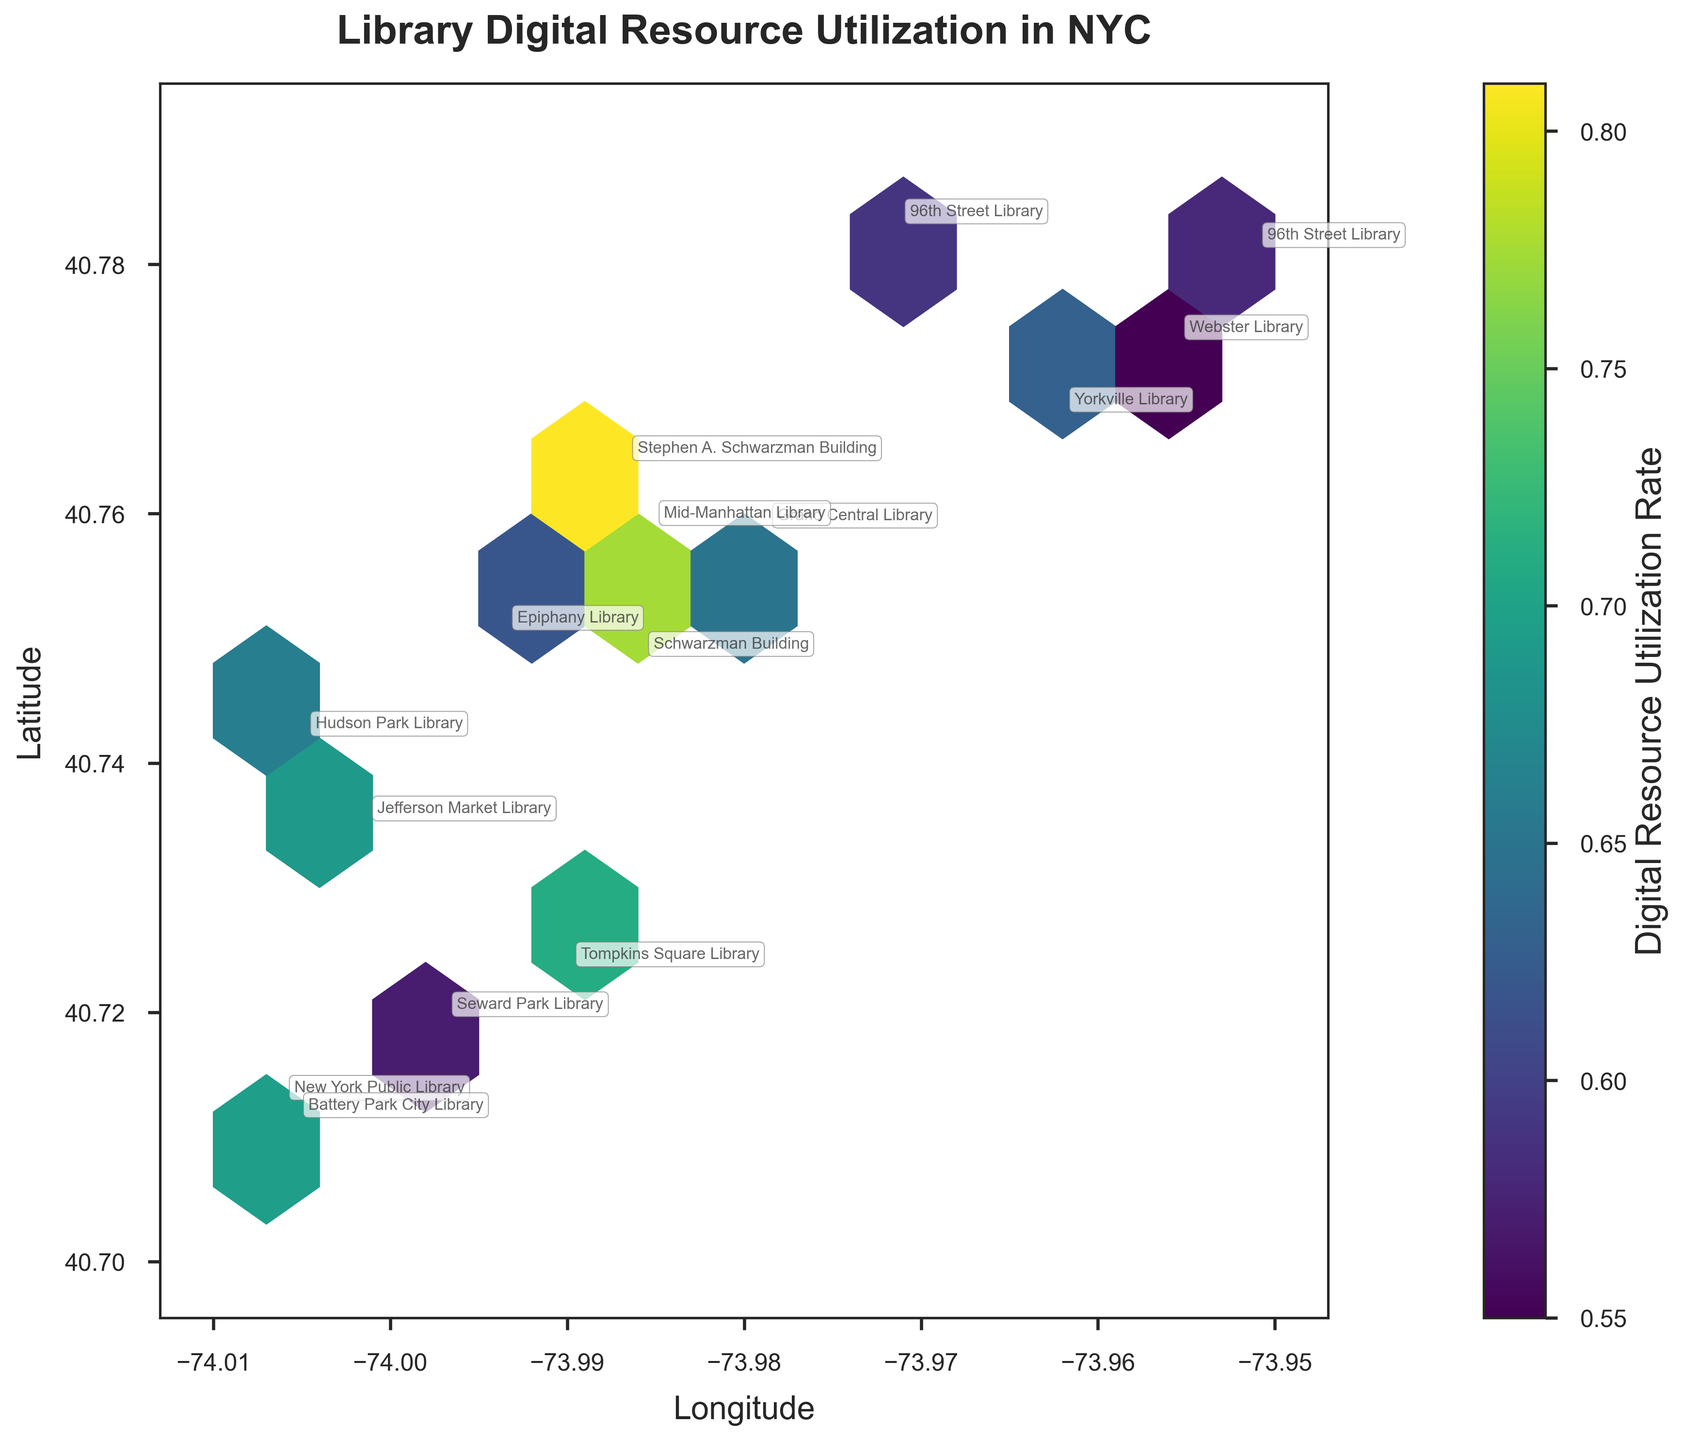What is the title of the plot? The title of a plot is usually prominently displayed at the top. In this case, it says "Library Digital Resource Utilization in NYC".
Answer: Library Digital Resource Utilization in NYC What is the color representing in this plot? The color of the hexagons indicates the "Digital Resource Utilization Rate", as described by the color bar on the right side of the plot.
Answer: Digital Resource Utilization Rate How many libraries are annotated in the plot? One way to count the annotated libraries is to look at each hexagon and count the distinct library names next to them. In this case, there are 15 unique annotations in the plot.
Answer: 15 Which library has the highest digital resource utilization rate, and where is it located? By referring to the annotations and color intensity of the hexagons, the Schwarzman Building has one of the highest rates, specifically noted at two locations with rates of 0.82 and 0.81. This is determined by identifying the deepest colored hexagons and checking their annotations.
Answer: Schwarzman Building, Latitude 40.7484 and Longitude -73.9857 Are there any two libraries located at the same latitude and longitude? If so, which one(s)? Yes, the 96th Street Library is annotated twice but with slightly different utilization rates. Their coordinates are both (Latitude 40.7831, Longitude -73.9712) and (Latitude 40.7812, Longitude -73.9510).
Answer: 96th Street Library Which area appears to have the highest density of libraries using digital resources? By looking at the cluster of hexagons, the area between latitudes 40.75 and 40.76 and longitudes -73.99 to -73.97 seems to have the highest density of libraries using digital resources, indicated by several closely packed hexagons in varying strong colors.
Answer: Latitude 40.75 to 40.76, Longitude -73.99 to -73.97 What does a deep blue-green hexagon imply about the digital resource utilization rate? The color represents lower to moderate digital resource utilization rates according to the color gradient provided by the color bar. Lighter colors indicate higher utilization rates.
Answer: Low to moderate digital resource utilization rate Compare the digital resource utilization rates of Battery Park City Library and Yorkville Library. Which one has a higher rate? By identifying the annotations and corresponding colors, Battery Park City Library has a rate of 0.61, while Yorkville Library has a rate of 0.63. Thus, Yorkville Library has a slightly higher rate.
Answer: Yorkville Library What is the digital resource utilization rate of Hudson Park Library? Look for the annotation labeled "Hudson Park Library” and match it with the colored hexagon. According to the plot, Hudson Park Library has a rate of 0.66.
Answer: 0.66 Which library has the lowest digital resource utilization rate, and what is its value? By looking at the color scale and finding the least intense colored annotations, Webster Library has the lowest utilization rate represented in the plot, which is 0.55.
Answer: Webster Library, 0.55 